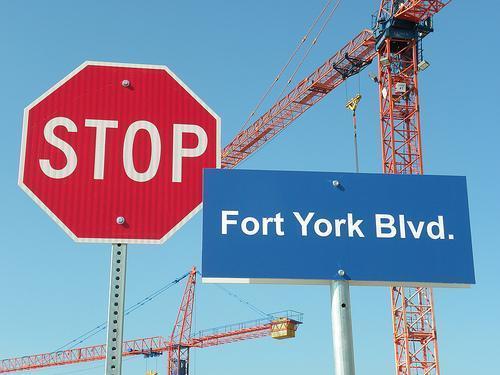How many signs are there?
Give a very brief answer. 2. 